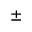<formula> <loc_0><loc_0><loc_500><loc_500>\pm</formula> 